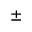<formula> <loc_0><loc_0><loc_500><loc_500>\pm</formula> 